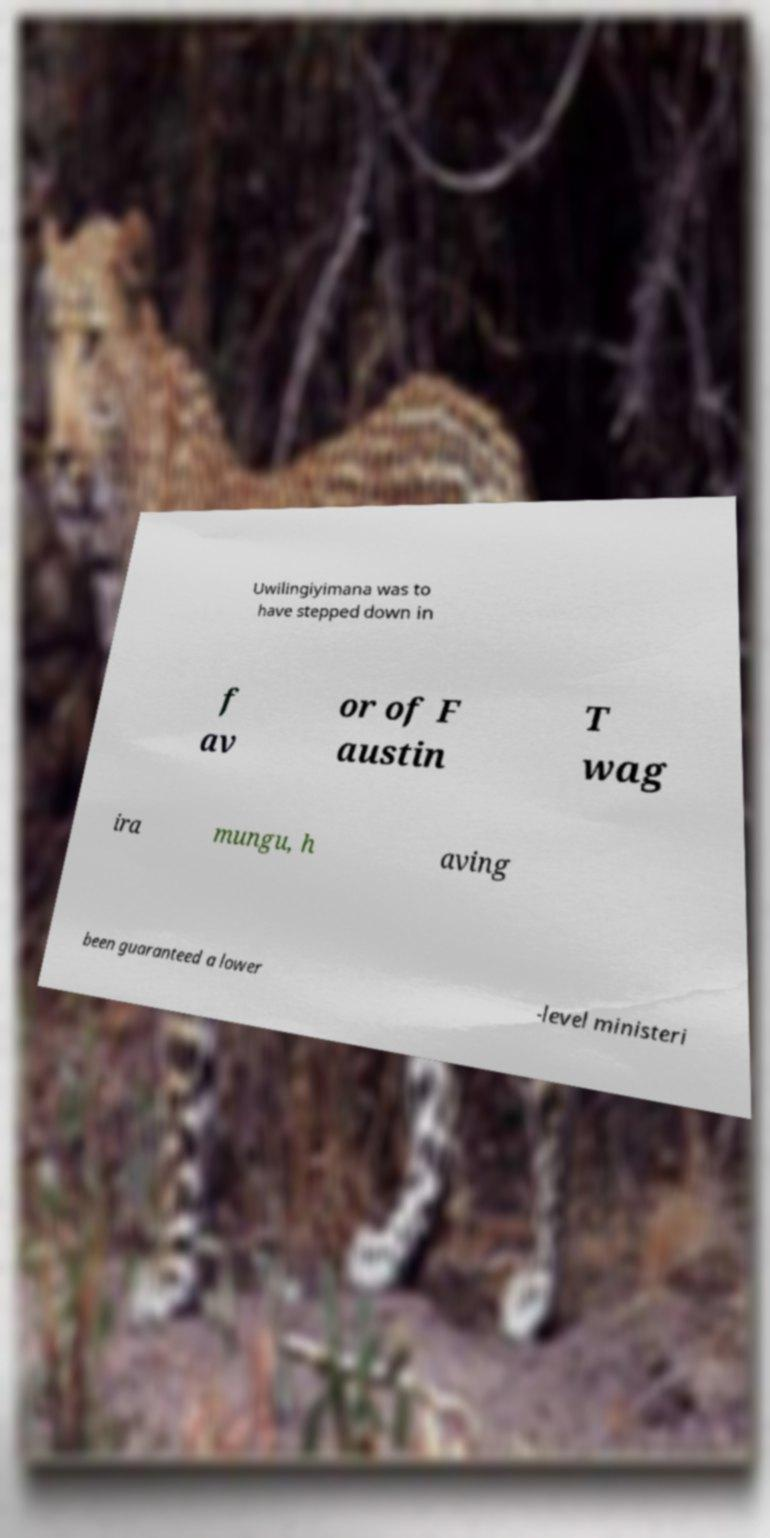What messages or text are displayed in this image? I need them in a readable, typed format. Uwilingiyimana was to have stepped down in f av or of F austin T wag ira mungu, h aving been guaranteed a lower -level ministeri 